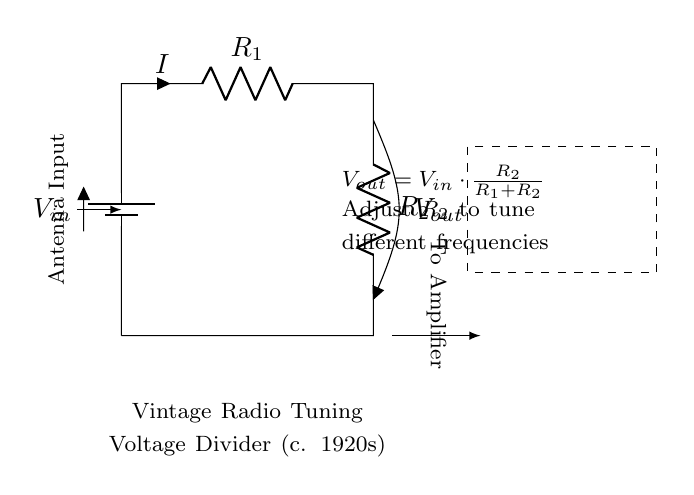What is the input voltage of the circuit? The input voltage, labeled as \( V_{in} \), is a key component in this voltage divider circuit and is indicated at the top of the battery symbol. The exact voltage value is not specified, but it is understood to be the supply voltage for the circuit.
Answer: \( V_{in} \) What are the resistances used in the circuit? The circuit shows two resistors labeled as \( R_1 \) and \( R_2 \). This means that these are the two resistances in the voltage divider which divide the input voltage. Their specific values are not given but they are standard identifiers in such circuits.
Answer: \( R_1, R_2 \) What is the function of \( R_2 \) in this circuit? \( R_2 \) serves to determine the output voltage, \( V_{out} \). According to the voltage divider formula, adjusting \( R_2 \) changes the ratio of the resistances and therefore the amount of voltage dropped across each resistor. This allows for tuning different frequencies in vintage radio equipment.
Answer: To tune frequencies What does the output voltage \( V_{out} \) depend on? The output voltage \( V_{out} \) is calculated using the voltage divider formula \( V_{out} = V_{in} \cdot \frac{R_2}{R_1 + R_2} \). This indicates that \( V_{out} \) is directly proportional to \( R_2 \) and inversely proportional to the total resistance \( (R_1 + R_2) \). Thus, the adjustment of either resistor will impact the output voltage.
Answer: \( V_{in}, R_1, R_2 \) How is the current labeled in the circuit? The current in the circuit is represented by the symbol \( I \) with an arrow indicating the direction of current flow. It is labeled at the resistor \( R_1 \), showing that current flows through this resistor as part of the circuit functionality.
Answer: \( I \) What does the dashed box represent in the diagram? The dashed box encloses information about the function of the circuit, which provides context for the components involved. It summarizes that the circuit is for a vintage radio tuning voltage divider from the 1920s, aiding in understanding the purpose of the diagram and the historical significance.
Answer: Vintage radio tuning 